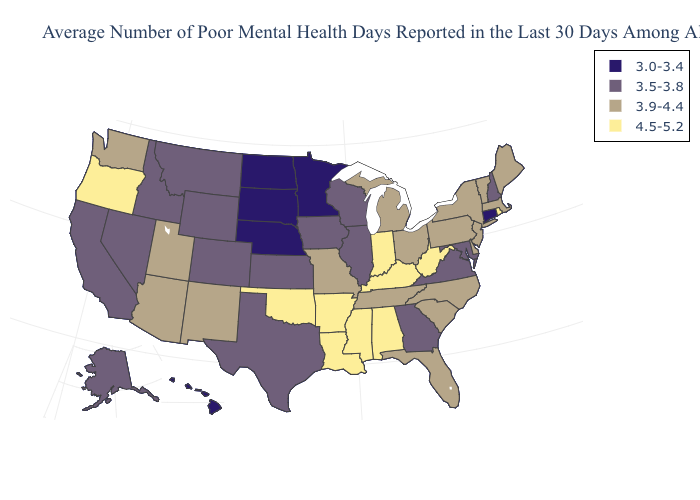Name the states that have a value in the range 3.0-3.4?
Quick response, please. Connecticut, Hawaii, Minnesota, Nebraska, North Dakota, South Dakota. Does the first symbol in the legend represent the smallest category?
Concise answer only. Yes. What is the lowest value in states that border Florida?
Keep it brief. 3.5-3.8. What is the value of Michigan?
Give a very brief answer. 3.9-4.4. What is the value of Delaware?
Short answer required. 3.9-4.4. Which states hav the highest value in the South?
Give a very brief answer. Alabama, Arkansas, Kentucky, Louisiana, Mississippi, Oklahoma, West Virginia. Name the states that have a value in the range 4.5-5.2?
Quick response, please. Alabama, Arkansas, Indiana, Kentucky, Louisiana, Mississippi, Oklahoma, Oregon, Rhode Island, West Virginia. What is the highest value in states that border North Carolina?
Answer briefly. 3.9-4.4. Does Hawaii have the lowest value in the West?
Concise answer only. Yes. Name the states that have a value in the range 4.5-5.2?
Answer briefly. Alabama, Arkansas, Indiana, Kentucky, Louisiana, Mississippi, Oklahoma, Oregon, Rhode Island, West Virginia. Does the first symbol in the legend represent the smallest category?
Give a very brief answer. Yes. Does Missouri have the highest value in the MidWest?
Concise answer only. No. What is the lowest value in the USA?
Answer briefly. 3.0-3.4. Among the states that border Louisiana , which have the highest value?
Short answer required. Arkansas, Mississippi. Name the states that have a value in the range 3.5-3.8?
Answer briefly. Alaska, California, Colorado, Georgia, Idaho, Illinois, Iowa, Kansas, Maryland, Montana, Nevada, New Hampshire, Texas, Virginia, Wisconsin, Wyoming. 